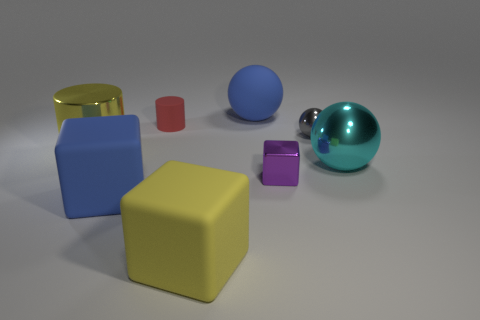Add 1 large cubes. How many objects exist? 9 Subtract all cylinders. How many objects are left? 6 Subtract all purple metal spheres. Subtract all metallic things. How many objects are left? 4 Add 8 small purple blocks. How many small purple blocks are left? 9 Add 4 tiny rubber objects. How many tiny rubber objects exist? 5 Subtract 0 brown cubes. How many objects are left? 8 